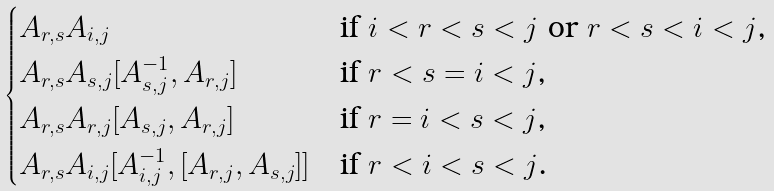<formula> <loc_0><loc_0><loc_500><loc_500>\begin{cases} A _ { r , s } A _ { i , j } & \text {if $i<r<s<j$ or $r<s<i<j$,} \\ A _ { r , s } A _ { s , j } [ A _ { s , j } ^ { - 1 } , A _ { r , j } ] & \text {if $r<s=i<j$,} \\ A _ { r , s } A _ { r , j } [ A _ { s , j } , A _ { r , j } ] & \text {if $r=i<s<j$,} \\ A _ { r , s } A _ { i , j } [ A _ { i , j } ^ { - 1 } , [ A _ { r , j } , A _ { s , j } ] ] & \text {if $r<i<s<j$.} \end{cases}</formula> 